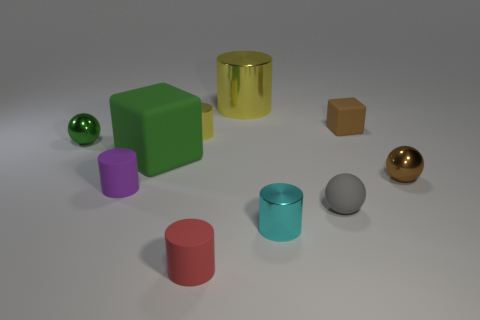Subtract 2 cylinders. How many cylinders are left? 3 Subtract all blue cylinders. Subtract all brown blocks. How many cylinders are left? 5 Subtract all balls. How many objects are left? 7 Subtract 0 gray cylinders. How many objects are left? 10 Subtract all big brown blocks. Subtract all small cylinders. How many objects are left? 6 Add 3 small purple matte things. How many small purple matte things are left? 4 Add 5 red cylinders. How many red cylinders exist? 6 